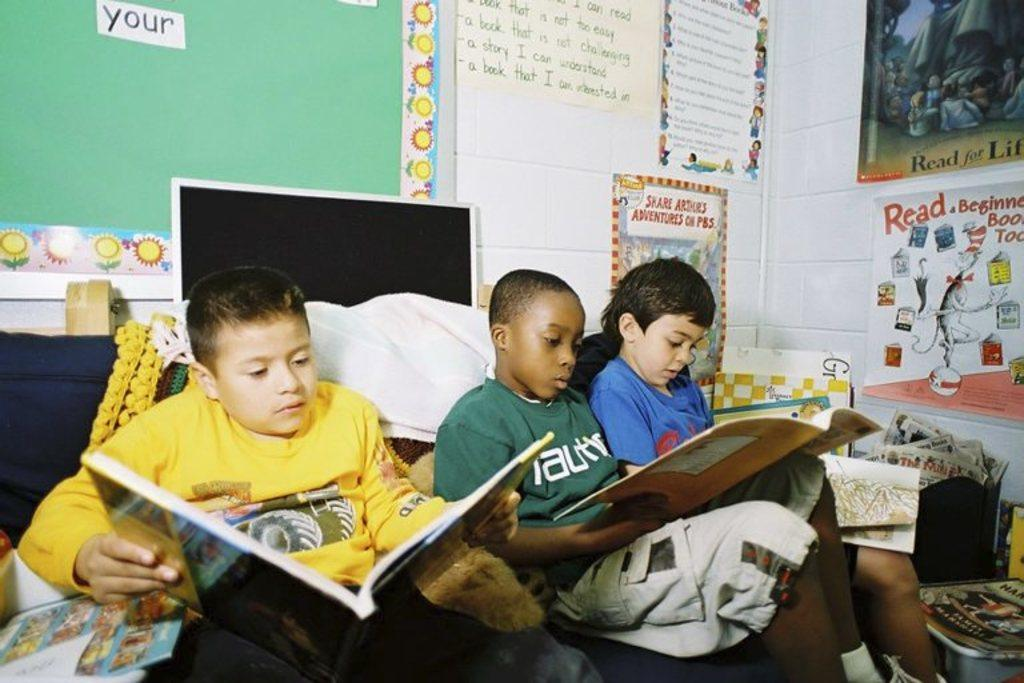<image>
Relay a brief, clear account of the picture shown. Boys reading a book in front of a green board that has the word "your" on it. 